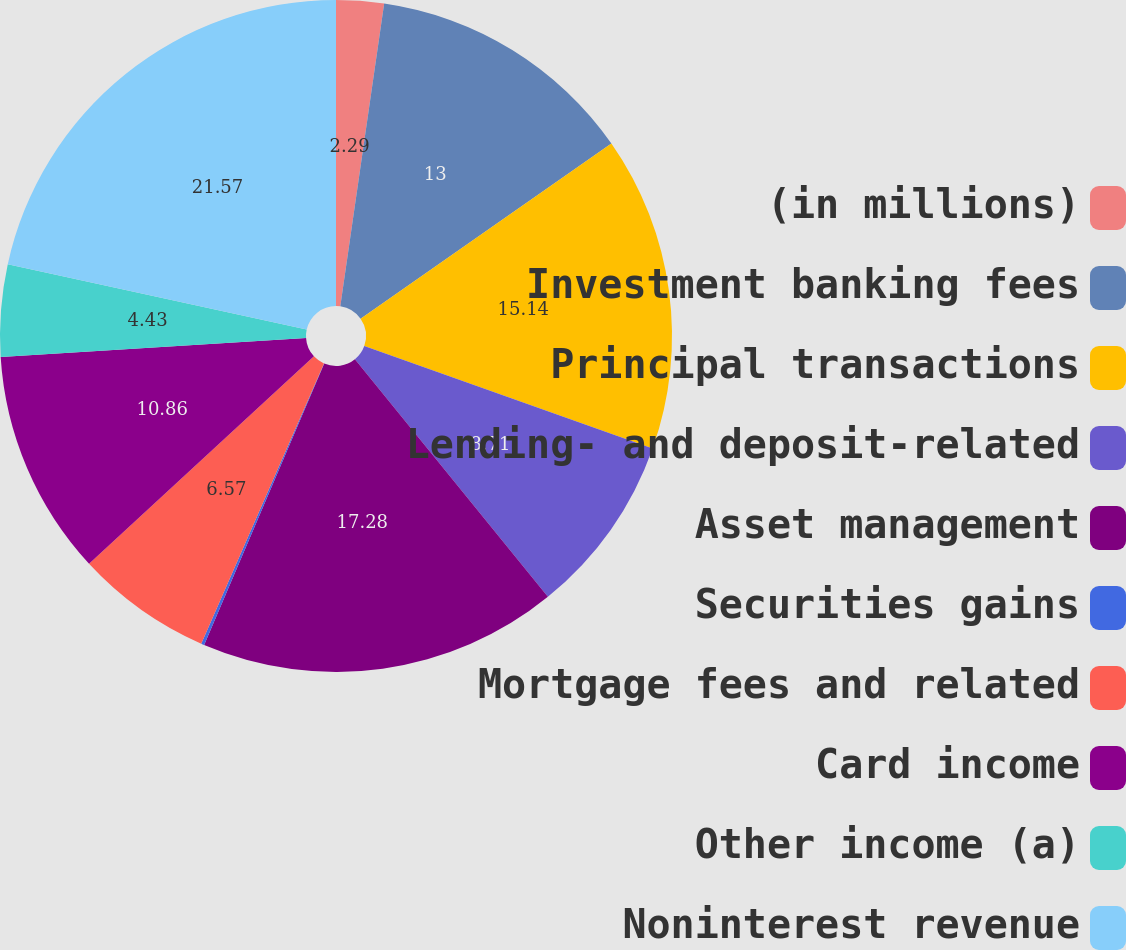<chart> <loc_0><loc_0><loc_500><loc_500><pie_chart><fcel>(in millions)<fcel>Investment banking fees<fcel>Principal transactions<fcel>Lending- and deposit-related<fcel>Asset management<fcel>Securities gains<fcel>Mortgage fees and related<fcel>Card income<fcel>Other income (a)<fcel>Noninterest revenue<nl><fcel>2.29%<fcel>13.0%<fcel>15.14%<fcel>8.71%<fcel>17.28%<fcel>0.15%<fcel>6.57%<fcel>10.86%<fcel>4.43%<fcel>21.57%<nl></chart> 